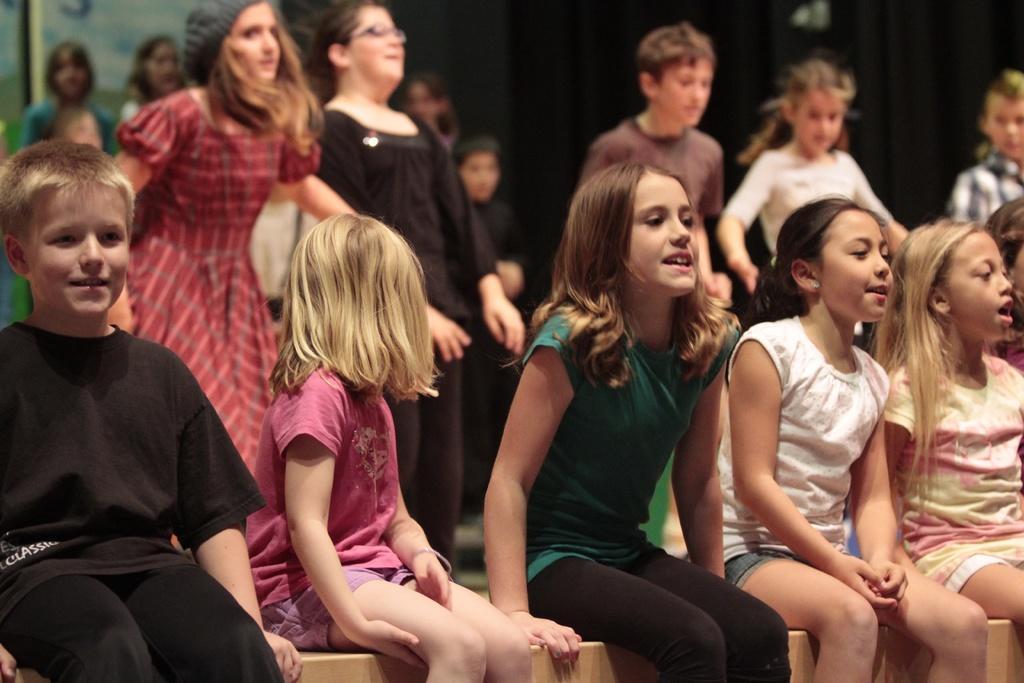Describe this image in one or two sentences. In this picture we can see a few kids on the bench. There are some people visible at the back. We can see a black background. 